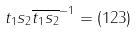<formula> <loc_0><loc_0><loc_500><loc_500>t _ { 1 } s _ { 2 } \overline { t _ { 1 } s _ { 2 } } ^ { - 1 } = ( 1 2 3 )</formula> 